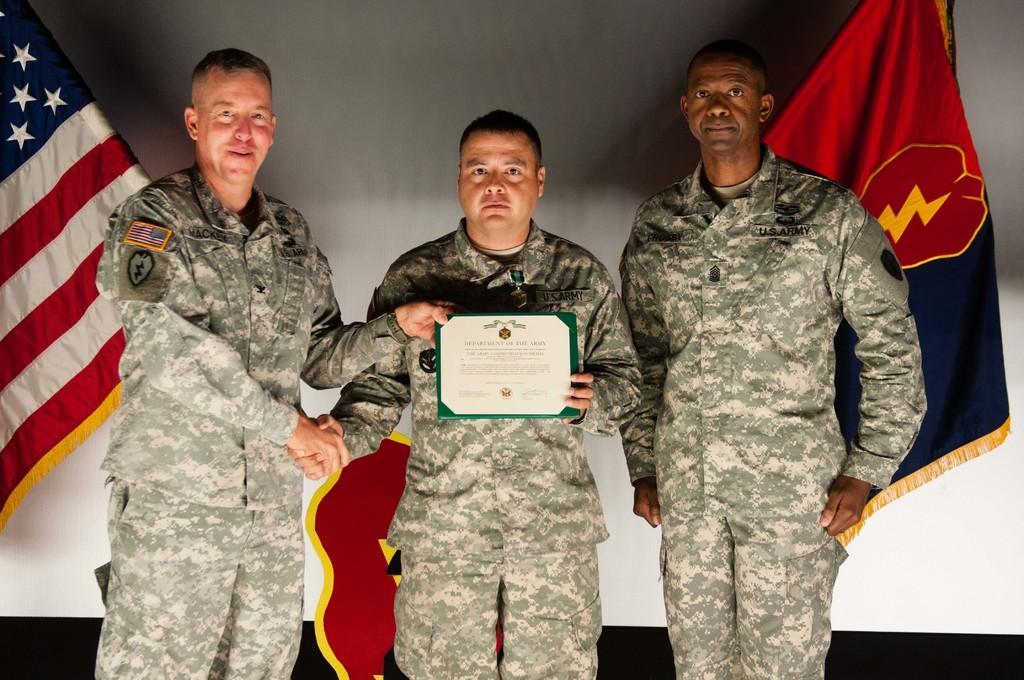Describe this image in one or two sentences. In this image I can see three persons wearing uniforms are standing and I can see two of them are holding white and green colored object. In the background I can see the white colored surface and two flags. 